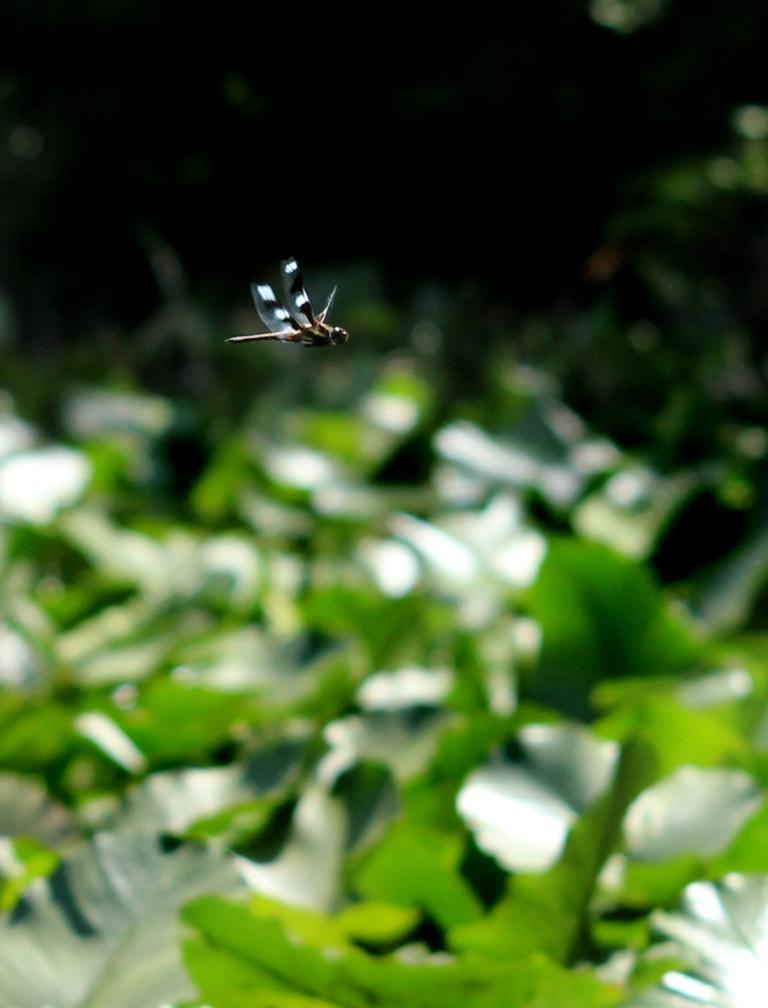What type of insect is in the image? There is a dragonfly in the image. Where is the dragonfly located in the image? The dragonfly is in the air. What can be seen in the background of the image? There are leaves visible in the background of the image. What type of shirt is the dragonfly wearing in the image? Dragonflies do not wear shirts, as they are insects and do not have the ability to wear clothing. 